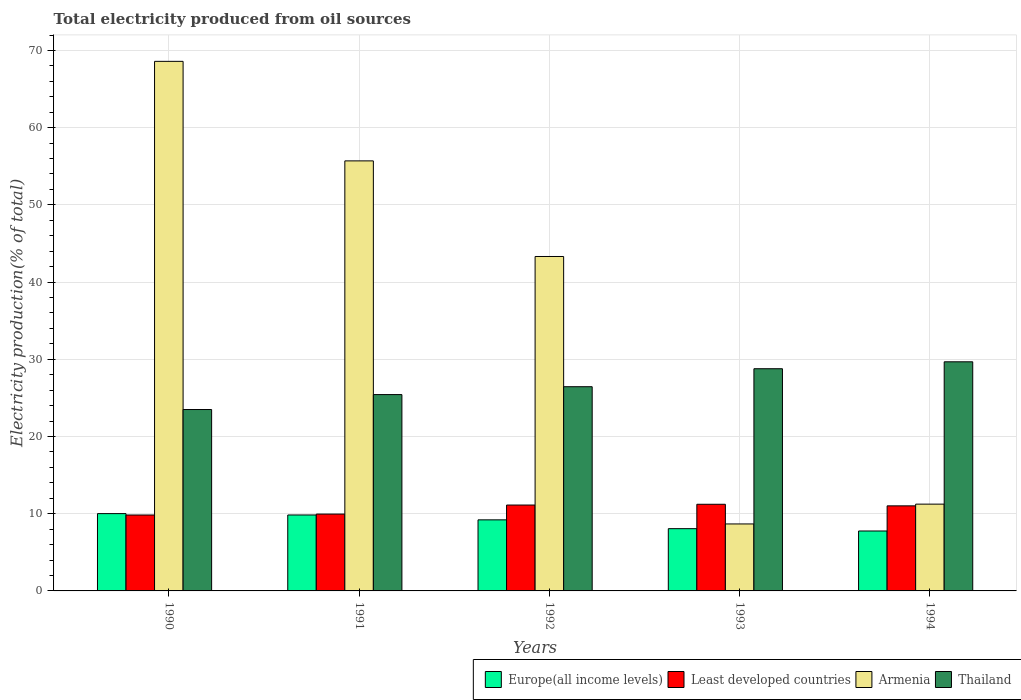How many bars are there on the 2nd tick from the right?
Keep it short and to the point. 4. What is the label of the 3rd group of bars from the left?
Provide a succinct answer. 1992. In how many cases, is the number of bars for a given year not equal to the number of legend labels?
Make the answer very short. 0. What is the total electricity produced in Least developed countries in 1991?
Your answer should be compact. 9.95. Across all years, what is the maximum total electricity produced in Thailand?
Offer a very short reply. 29.67. Across all years, what is the minimum total electricity produced in Armenia?
Make the answer very short. 8.67. What is the total total electricity produced in Europe(all income levels) in the graph?
Offer a terse response. 44.88. What is the difference between the total electricity produced in Armenia in 1993 and that in 1994?
Give a very brief answer. -2.57. What is the difference between the total electricity produced in Europe(all income levels) in 1994 and the total electricity produced in Thailand in 1990?
Give a very brief answer. -15.73. What is the average total electricity produced in Thailand per year?
Ensure brevity in your answer.  26.76. In the year 1993, what is the difference between the total electricity produced in Thailand and total electricity produced in Armenia?
Offer a terse response. 20.1. In how many years, is the total electricity produced in Least developed countries greater than 34 %?
Provide a short and direct response. 0. What is the ratio of the total electricity produced in Europe(all income levels) in 1990 to that in 1994?
Offer a terse response. 1.29. Is the total electricity produced in Armenia in 1990 less than that in 1992?
Your answer should be compact. No. What is the difference between the highest and the second highest total electricity produced in Least developed countries?
Ensure brevity in your answer.  0.1. What is the difference between the highest and the lowest total electricity produced in Least developed countries?
Provide a short and direct response. 1.39. In how many years, is the total electricity produced in Thailand greater than the average total electricity produced in Thailand taken over all years?
Your response must be concise. 2. Is it the case that in every year, the sum of the total electricity produced in Thailand and total electricity produced in Least developed countries is greater than the sum of total electricity produced in Europe(all income levels) and total electricity produced in Armenia?
Ensure brevity in your answer.  Yes. What does the 1st bar from the left in 1994 represents?
Your answer should be compact. Europe(all income levels). What does the 4th bar from the right in 1990 represents?
Offer a very short reply. Europe(all income levels). How many years are there in the graph?
Your answer should be compact. 5. What is the difference between two consecutive major ticks on the Y-axis?
Offer a terse response. 10. Are the values on the major ticks of Y-axis written in scientific E-notation?
Provide a short and direct response. No. How are the legend labels stacked?
Your answer should be compact. Horizontal. What is the title of the graph?
Your answer should be compact. Total electricity produced from oil sources. Does "Isle of Man" appear as one of the legend labels in the graph?
Keep it short and to the point. No. What is the label or title of the X-axis?
Your answer should be very brief. Years. What is the Electricity production(% of total) of Europe(all income levels) in 1990?
Give a very brief answer. 10.01. What is the Electricity production(% of total) in Least developed countries in 1990?
Provide a short and direct response. 9.83. What is the Electricity production(% of total) in Armenia in 1990?
Ensure brevity in your answer.  68.59. What is the Electricity production(% of total) of Thailand in 1990?
Make the answer very short. 23.49. What is the Electricity production(% of total) in Europe(all income levels) in 1991?
Give a very brief answer. 9.84. What is the Electricity production(% of total) of Least developed countries in 1991?
Give a very brief answer. 9.95. What is the Electricity production(% of total) in Armenia in 1991?
Give a very brief answer. 55.7. What is the Electricity production(% of total) of Thailand in 1991?
Provide a succinct answer. 25.43. What is the Electricity production(% of total) of Europe(all income levels) in 1992?
Provide a succinct answer. 9.2. What is the Electricity production(% of total) in Least developed countries in 1992?
Make the answer very short. 11.12. What is the Electricity production(% of total) in Armenia in 1992?
Ensure brevity in your answer.  43.31. What is the Electricity production(% of total) in Thailand in 1992?
Offer a very short reply. 26.45. What is the Electricity production(% of total) of Europe(all income levels) in 1993?
Give a very brief answer. 8.06. What is the Electricity production(% of total) of Least developed countries in 1993?
Make the answer very short. 11.22. What is the Electricity production(% of total) in Armenia in 1993?
Provide a succinct answer. 8.67. What is the Electricity production(% of total) of Thailand in 1993?
Give a very brief answer. 28.78. What is the Electricity production(% of total) of Europe(all income levels) in 1994?
Your answer should be very brief. 7.76. What is the Electricity production(% of total) of Least developed countries in 1994?
Make the answer very short. 11.02. What is the Electricity production(% of total) of Armenia in 1994?
Keep it short and to the point. 11.24. What is the Electricity production(% of total) in Thailand in 1994?
Provide a short and direct response. 29.67. Across all years, what is the maximum Electricity production(% of total) of Europe(all income levels)?
Give a very brief answer. 10.01. Across all years, what is the maximum Electricity production(% of total) of Least developed countries?
Provide a succinct answer. 11.22. Across all years, what is the maximum Electricity production(% of total) in Armenia?
Ensure brevity in your answer.  68.59. Across all years, what is the maximum Electricity production(% of total) of Thailand?
Your answer should be compact. 29.67. Across all years, what is the minimum Electricity production(% of total) in Europe(all income levels)?
Your answer should be very brief. 7.76. Across all years, what is the minimum Electricity production(% of total) of Least developed countries?
Your response must be concise. 9.83. Across all years, what is the minimum Electricity production(% of total) in Armenia?
Keep it short and to the point. 8.67. Across all years, what is the minimum Electricity production(% of total) in Thailand?
Provide a short and direct response. 23.49. What is the total Electricity production(% of total) of Europe(all income levels) in the graph?
Provide a short and direct response. 44.88. What is the total Electricity production(% of total) in Least developed countries in the graph?
Give a very brief answer. 53.15. What is the total Electricity production(% of total) in Armenia in the graph?
Ensure brevity in your answer.  187.51. What is the total Electricity production(% of total) in Thailand in the graph?
Offer a very short reply. 133.82. What is the difference between the Electricity production(% of total) in Europe(all income levels) in 1990 and that in 1991?
Your response must be concise. 0.18. What is the difference between the Electricity production(% of total) in Least developed countries in 1990 and that in 1991?
Make the answer very short. -0.12. What is the difference between the Electricity production(% of total) of Armenia in 1990 and that in 1991?
Your response must be concise. 12.89. What is the difference between the Electricity production(% of total) of Thailand in 1990 and that in 1991?
Offer a very short reply. -1.93. What is the difference between the Electricity production(% of total) in Europe(all income levels) in 1990 and that in 1992?
Give a very brief answer. 0.81. What is the difference between the Electricity production(% of total) of Least developed countries in 1990 and that in 1992?
Ensure brevity in your answer.  -1.29. What is the difference between the Electricity production(% of total) in Armenia in 1990 and that in 1992?
Keep it short and to the point. 25.27. What is the difference between the Electricity production(% of total) in Thailand in 1990 and that in 1992?
Offer a very short reply. -2.95. What is the difference between the Electricity production(% of total) of Europe(all income levels) in 1990 and that in 1993?
Give a very brief answer. 1.95. What is the difference between the Electricity production(% of total) in Least developed countries in 1990 and that in 1993?
Keep it short and to the point. -1.39. What is the difference between the Electricity production(% of total) of Armenia in 1990 and that in 1993?
Provide a short and direct response. 59.91. What is the difference between the Electricity production(% of total) in Thailand in 1990 and that in 1993?
Make the answer very short. -5.28. What is the difference between the Electricity production(% of total) in Europe(all income levels) in 1990 and that in 1994?
Ensure brevity in your answer.  2.25. What is the difference between the Electricity production(% of total) in Least developed countries in 1990 and that in 1994?
Keep it short and to the point. -1.19. What is the difference between the Electricity production(% of total) in Armenia in 1990 and that in 1994?
Ensure brevity in your answer.  57.35. What is the difference between the Electricity production(% of total) of Thailand in 1990 and that in 1994?
Your response must be concise. -6.18. What is the difference between the Electricity production(% of total) of Europe(all income levels) in 1991 and that in 1992?
Provide a succinct answer. 0.63. What is the difference between the Electricity production(% of total) in Least developed countries in 1991 and that in 1992?
Offer a very short reply. -1.17. What is the difference between the Electricity production(% of total) of Armenia in 1991 and that in 1992?
Keep it short and to the point. 12.38. What is the difference between the Electricity production(% of total) in Thailand in 1991 and that in 1992?
Offer a very short reply. -1.02. What is the difference between the Electricity production(% of total) of Europe(all income levels) in 1991 and that in 1993?
Give a very brief answer. 1.77. What is the difference between the Electricity production(% of total) of Least developed countries in 1991 and that in 1993?
Provide a short and direct response. -1.27. What is the difference between the Electricity production(% of total) of Armenia in 1991 and that in 1993?
Offer a very short reply. 47.02. What is the difference between the Electricity production(% of total) of Thailand in 1991 and that in 1993?
Your answer should be very brief. -3.35. What is the difference between the Electricity production(% of total) of Europe(all income levels) in 1991 and that in 1994?
Provide a succinct answer. 2.08. What is the difference between the Electricity production(% of total) of Least developed countries in 1991 and that in 1994?
Ensure brevity in your answer.  -1.06. What is the difference between the Electricity production(% of total) of Armenia in 1991 and that in 1994?
Make the answer very short. 44.45. What is the difference between the Electricity production(% of total) of Thailand in 1991 and that in 1994?
Offer a terse response. -4.25. What is the difference between the Electricity production(% of total) of Europe(all income levels) in 1992 and that in 1993?
Your answer should be very brief. 1.14. What is the difference between the Electricity production(% of total) in Least developed countries in 1992 and that in 1993?
Give a very brief answer. -0.1. What is the difference between the Electricity production(% of total) of Armenia in 1992 and that in 1993?
Make the answer very short. 34.64. What is the difference between the Electricity production(% of total) in Thailand in 1992 and that in 1993?
Your answer should be compact. -2.33. What is the difference between the Electricity production(% of total) of Europe(all income levels) in 1992 and that in 1994?
Provide a succinct answer. 1.44. What is the difference between the Electricity production(% of total) in Least developed countries in 1992 and that in 1994?
Make the answer very short. 0.11. What is the difference between the Electricity production(% of total) in Armenia in 1992 and that in 1994?
Provide a succinct answer. 32.07. What is the difference between the Electricity production(% of total) in Thailand in 1992 and that in 1994?
Offer a terse response. -3.23. What is the difference between the Electricity production(% of total) of Europe(all income levels) in 1993 and that in 1994?
Provide a succinct answer. 0.3. What is the difference between the Electricity production(% of total) of Least developed countries in 1993 and that in 1994?
Your response must be concise. 0.21. What is the difference between the Electricity production(% of total) in Armenia in 1993 and that in 1994?
Keep it short and to the point. -2.57. What is the difference between the Electricity production(% of total) in Thailand in 1993 and that in 1994?
Keep it short and to the point. -0.9. What is the difference between the Electricity production(% of total) of Europe(all income levels) in 1990 and the Electricity production(% of total) of Least developed countries in 1991?
Your answer should be very brief. 0.06. What is the difference between the Electricity production(% of total) in Europe(all income levels) in 1990 and the Electricity production(% of total) in Armenia in 1991?
Make the answer very short. -45.68. What is the difference between the Electricity production(% of total) in Europe(all income levels) in 1990 and the Electricity production(% of total) in Thailand in 1991?
Keep it short and to the point. -15.42. What is the difference between the Electricity production(% of total) of Least developed countries in 1990 and the Electricity production(% of total) of Armenia in 1991?
Ensure brevity in your answer.  -45.86. What is the difference between the Electricity production(% of total) in Least developed countries in 1990 and the Electricity production(% of total) in Thailand in 1991?
Your answer should be very brief. -15.6. What is the difference between the Electricity production(% of total) of Armenia in 1990 and the Electricity production(% of total) of Thailand in 1991?
Your answer should be compact. 43.16. What is the difference between the Electricity production(% of total) of Europe(all income levels) in 1990 and the Electricity production(% of total) of Least developed countries in 1992?
Make the answer very short. -1.11. What is the difference between the Electricity production(% of total) of Europe(all income levels) in 1990 and the Electricity production(% of total) of Armenia in 1992?
Your answer should be compact. -33.3. What is the difference between the Electricity production(% of total) of Europe(all income levels) in 1990 and the Electricity production(% of total) of Thailand in 1992?
Offer a terse response. -16.44. What is the difference between the Electricity production(% of total) of Least developed countries in 1990 and the Electricity production(% of total) of Armenia in 1992?
Provide a short and direct response. -33.48. What is the difference between the Electricity production(% of total) of Least developed countries in 1990 and the Electricity production(% of total) of Thailand in 1992?
Give a very brief answer. -16.62. What is the difference between the Electricity production(% of total) of Armenia in 1990 and the Electricity production(% of total) of Thailand in 1992?
Keep it short and to the point. 42.14. What is the difference between the Electricity production(% of total) in Europe(all income levels) in 1990 and the Electricity production(% of total) in Least developed countries in 1993?
Provide a short and direct response. -1.21. What is the difference between the Electricity production(% of total) in Europe(all income levels) in 1990 and the Electricity production(% of total) in Armenia in 1993?
Provide a short and direct response. 1.34. What is the difference between the Electricity production(% of total) of Europe(all income levels) in 1990 and the Electricity production(% of total) of Thailand in 1993?
Provide a succinct answer. -18.77. What is the difference between the Electricity production(% of total) of Least developed countries in 1990 and the Electricity production(% of total) of Armenia in 1993?
Keep it short and to the point. 1.16. What is the difference between the Electricity production(% of total) of Least developed countries in 1990 and the Electricity production(% of total) of Thailand in 1993?
Make the answer very short. -18.95. What is the difference between the Electricity production(% of total) in Armenia in 1990 and the Electricity production(% of total) in Thailand in 1993?
Make the answer very short. 39.81. What is the difference between the Electricity production(% of total) in Europe(all income levels) in 1990 and the Electricity production(% of total) in Least developed countries in 1994?
Make the answer very short. -1.01. What is the difference between the Electricity production(% of total) of Europe(all income levels) in 1990 and the Electricity production(% of total) of Armenia in 1994?
Keep it short and to the point. -1.23. What is the difference between the Electricity production(% of total) in Europe(all income levels) in 1990 and the Electricity production(% of total) in Thailand in 1994?
Give a very brief answer. -19.66. What is the difference between the Electricity production(% of total) in Least developed countries in 1990 and the Electricity production(% of total) in Armenia in 1994?
Provide a short and direct response. -1.41. What is the difference between the Electricity production(% of total) in Least developed countries in 1990 and the Electricity production(% of total) in Thailand in 1994?
Offer a terse response. -19.84. What is the difference between the Electricity production(% of total) in Armenia in 1990 and the Electricity production(% of total) in Thailand in 1994?
Your response must be concise. 38.91. What is the difference between the Electricity production(% of total) of Europe(all income levels) in 1991 and the Electricity production(% of total) of Least developed countries in 1992?
Provide a short and direct response. -1.29. What is the difference between the Electricity production(% of total) in Europe(all income levels) in 1991 and the Electricity production(% of total) in Armenia in 1992?
Your answer should be compact. -33.48. What is the difference between the Electricity production(% of total) of Europe(all income levels) in 1991 and the Electricity production(% of total) of Thailand in 1992?
Ensure brevity in your answer.  -16.61. What is the difference between the Electricity production(% of total) in Least developed countries in 1991 and the Electricity production(% of total) in Armenia in 1992?
Ensure brevity in your answer.  -33.36. What is the difference between the Electricity production(% of total) of Least developed countries in 1991 and the Electricity production(% of total) of Thailand in 1992?
Ensure brevity in your answer.  -16.49. What is the difference between the Electricity production(% of total) of Armenia in 1991 and the Electricity production(% of total) of Thailand in 1992?
Provide a succinct answer. 29.25. What is the difference between the Electricity production(% of total) in Europe(all income levels) in 1991 and the Electricity production(% of total) in Least developed countries in 1993?
Provide a succinct answer. -1.39. What is the difference between the Electricity production(% of total) of Europe(all income levels) in 1991 and the Electricity production(% of total) of Armenia in 1993?
Offer a very short reply. 1.16. What is the difference between the Electricity production(% of total) in Europe(all income levels) in 1991 and the Electricity production(% of total) in Thailand in 1993?
Give a very brief answer. -18.94. What is the difference between the Electricity production(% of total) of Least developed countries in 1991 and the Electricity production(% of total) of Armenia in 1993?
Your answer should be very brief. 1.28. What is the difference between the Electricity production(% of total) of Least developed countries in 1991 and the Electricity production(% of total) of Thailand in 1993?
Your response must be concise. -18.82. What is the difference between the Electricity production(% of total) of Armenia in 1991 and the Electricity production(% of total) of Thailand in 1993?
Make the answer very short. 26.92. What is the difference between the Electricity production(% of total) of Europe(all income levels) in 1991 and the Electricity production(% of total) of Least developed countries in 1994?
Ensure brevity in your answer.  -1.18. What is the difference between the Electricity production(% of total) in Europe(all income levels) in 1991 and the Electricity production(% of total) in Armenia in 1994?
Offer a terse response. -1.4. What is the difference between the Electricity production(% of total) in Europe(all income levels) in 1991 and the Electricity production(% of total) in Thailand in 1994?
Ensure brevity in your answer.  -19.84. What is the difference between the Electricity production(% of total) in Least developed countries in 1991 and the Electricity production(% of total) in Armenia in 1994?
Your answer should be very brief. -1.29. What is the difference between the Electricity production(% of total) of Least developed countries in 1991 and the Electricity production(% of total) of Thailand in 1994?
Your response must be concise. -19.72. What is the difference between the Electricity production(% of total) of Armenia in 1991 and the Electricity production(% of total) of Thailand in 1994?
Offer a very short reply. 26.02. What is the difference between the Electricity production(% of total) of Europe(all income levels) in 1992 and the Electricity production(% of total) of Least developed countries in 1993?
Offer a very short reply. -2.02. What is the difference between the Electricity production(% of total) in Europe(all income levels) in 1992 and the Electricity production(% of total) in Armenia in 1993?
Your answer should be very brief. 0.53. What is the difference between the Electricity production(% of total) of Europe(all income levels) in 1992 and the Electricity production(% of total) of Thailand in 1993?
Ensure brevity in your answer.  -19.57. What is the difference between the Electricity production(% of total) of Least developed countries in 1992 and the Electricity production(% of total) of Armenia in 1993?
Provide a short and direct response. 2.45. What is the difference between the Electricity production(% of total) in Least developed countries in 1992 and the Electricity production(% of total) in Thailand in 1993?
Provide a short and direct response. -17.66. What is the difference between the Electricity production(% of total) in Armenia in 1992 and the Electricity production(% of total) in Thailand in 1993?
Give a very brief answer. 14.54. What is the difference between the Electricity production(% of total) of Europe(all income levels) in 1992 and the Electricity production(% of total) of Least developed countries in 1994?
Make the answer very short. -1.81. What is the difference between the Electricity production(% of total) of Europe(all income levels) in 1992 and the Electricity production(% of total) of Armenia in 1994?
Offer a very short reply. -2.04. What is the difference between the Electricity production(% of total) of Europe(all income levels) in 1992 and the Electricity production(% of total) of Thailand in 1994?
Your answer should be very brief. -20.47. What is the difference between the Electricity production(% of total) of Least developed countries in 1992 and the Electricity production(% of total) of Armenia in 1994?
Your response must be concise. -0.12. What is the difference between the Electricity production(% of total) in Least developed countries in 1992 and the Electricity production(% of total) in Thailand in 1994?
Provide a succinct answer. -18.55. What is the difference between the Electricity production(% of total) of Armenia in 1992 and the Electricity production(% of total) of Thailand in 1994?
Offer a terse response. 13.64. What is the difference between the Electricity production(% of total) of Europe(all income levels) in 1993 and the Electricity production(% of total) of Least developed countries in 1994?
Give a very brief answer. -2.95. What is the difference between the Electricity production(% of total) in Europe(all income levels) in 1993 and the Electricity production(% of total) in Armenia in 1994?
Provide a succinct answer. -3.18. What is the difference between the Electricity production(% of total) of Europe(all income levels) in 1993 and the Electricity production(% of total) of Thailand in 1994?
Your response must be concise. -21.61. What is the difference between the Electricity production(% of total) in Least developed countries in 1993 and the Electricity production(% of total) in Armenia in 1994?
Your answer should be very brief. -0.02. What is the difference between the Electricity production(% of total) of Least developed countries in 1993 and the Electricity production(% of total) of Thailand in 1994?
Provide a succinct answer. -18.45. What is the difference between the Electricity production(% of total) in Armenia in 1993 and the Electricity production(% of total) in Thailand in 1994?
Give a very brief answer. -21. What is the average Electricity production(% of total) in Europe(all income levels) per year?
Offer a very short reply. 8.98. What is the average Electricity production(% of total) in Least developed countries per year?
Ensure brevity in your answer.  10.63. What is the average Electricity production(% of total) of Armenia per year?
Ensure brevity in your answer.  37.5. What is the average Electricity production(% of total) in Thailand per year?
Your answer should be very brief. 26.76. In the year 1990, what is the difference between the Electricity production(% of total) in Europe(all income levels) and Electricity production(% of total) in Least developed countries?
Your answer should be compact. 0.18. In the year 1990, what is the difference between the Electricity production(% of total) in Europe(all income levels) and Electricity production(% of total) in Armenia?
Provide a succinct answer. -58.58. In the year 1990, what is the difference between the Electricity production(% of total) of Europe(all income levels) and Electricity production(% of total) of Thailand?
Offer a terse response. -13.48. In the year 1990, what is the difference between the Electricity production(% of total) of Least developed countries and Electricity production(% of total) of Armenia?
Offer a terse response. -58.76. In the year 1990, what is the difference between the Electricity production(% of total) in Least developed countries and Electricity production(% of total) in Thailand?
Your response must be concise. -13.66. In the year 1990, what is the difference between the Electricity production(% of total) of Armenia and Electricity production(% of total) of Thailand?
Offer a terse response. 45.09. In the year 1991, what is the difference between the Electricity production(% of total) of Europe(all income levels) and Electricity production(% of total) of Least developed countries?
Your response must be concise. -0.12. In the year 1991, what is the difference between the Electricity production(% of total) in Europe(all income levels) and Electricity production(% of total) in Armenia?
Your answer should be compact. -45.86. In the year 1991, what is the difference between the Electricity production(% of total) in Europe(all income levels) and Electricity production(% of total) in Thailand?
Provide a short and direct response. -15.59. In the year 1991, what is the difference between the Electricity production(% of total) in Least developed countries and Electricity production(% of total) in Armenia?
Your answer should be very brief. -45.74. In the year 1991, what is the difference between the Electricity production(% of total) in Least developed countries and Electricity production(% of total) in Thailand?
Make the answer very short. -15.47. In the year 1991, what is the difference between the Electricity production(% of total) of Armenia and Electricity production(% of total) of Thailand?
Provide a succinct answer. 30.27. In the year 1992, what is the difference between the Electricity production(% of total) in Europe(all income levels) and Electricity production(% of total) in Least developed countries?
Provide a short and direct response. -1.92. In the year 1992, what is the difference between the Electricity production(% of total) in Europe(all income levels) and Electricity production(% of total) in Armenia?
Your response must be concise. -34.11. In the year 1992, what is the difference between the Electricity production(% of total) of Europe(all income levels) and Electricity production(% of total) of Thailand?
Your answer should be compact. -17.24. In the year 1992, what is the difference between the Electricity production(% of total) in Least developed countries and Electricity production(% of total) in Armenia?
Your answer should be very brief. -32.19. In the year 1992, what is the difference between the Electricity production(% of total) of Least developed countries and Electricity production(% of total) of Thailand?
Provide a succinct answer. -15.33. In the year 1992, what is the difference between the Electricity production(% of total) in Armenia and Electricity production(% of total) in Thailand?
Keep it short and to the point. 16.87. In the year 1993, what is the difference between the Electricity production(% of total) of Europe(all income levels) and Electricity production(% of total) of Least developed countries?
Ensure brevity in your answer.  -3.16. In the year 1993, what is the difference between the Electricity production(% of total) of Europe(all income levels) and Electricity production(% of total) of Armenia?
Ensure brevity in your answer.  -0.61. In the year 1993, what is the difference between the Electricity production(% of total) in Europe(all income levels) and Electricity production(% of total) in Thailand?
Your answer should be compact. -20.71. In the year 1993, what is the difference between the Electricity production(% of total) in Least developed countries and Electricity production(% of total) in Armenia?
Give a very brief answer. 2.55. In the year 1993, what is the difference between the Electricity production(% of total) of Least developed countries and Electricity production(% of total) of Thailand?
Give a very brief answer. -17.55. In the year 1993, what is the difference between the Electricity production(% of total) in Armenia and Electricity production(% of total) in Thailand?
Provide a succinct answer. -20.1. In the year 1994, what is the difference between the Electricity production(% of total) of Europe(all income levels) and Electricity production(% of total) of Least developed countries?
Your answer should be very brief. -3.26. In the year 1994, what is the difference between the Electricity production(% of total) in Europe(all income levels) and Electricity production(% of total) in Armenia?
Make the answer very short. -3.48. In the year 1994, what is the difference between the Electricity production(% of total) of Europe(all income levels) and Electricity production(% of total) of Thailand?
Provide a succinct answer. -21.91. In the year 1994, what is the difference between the Electricity production(% of total) in Least developed countries and Electricity production(% of total) in Armenia?
Ensure brevity in your answer.  -0.22. In the year 1994, what is the difference between the Electricity production(% of total) in Least developed countries and Electricity production(% of total) in Thailand?
Offer a terse response. -18.66. In the year 1994, what is the difference between the Electricity production(% of total) in Armenia and Electricity production(% of total) in Thailand?
Ensure brevity in your answer.  -18.43. What is the ratio of the Electricity production(% of total) of Europe(all income levels) in 1990 to that in 1991?
Your answer should be compact. 1.02. What is the ratio of the Electricity production(% of total) in Least developed countries in 1990 to that in 1991?
Offer a very short reply. 0.99. What is the ratio of the Electricity production(% of total) in Armenia in 1990 to that in 1991?
Offer a very short reply. 1.23. What is the ratio of the Electricity production(% of total) in Thailand in 1990 to that in 1991?
Offer a very short reply. 0.92. What is the ratio of the Electricity production(% of total) in Europe(all income levels) in 1990 to that in 1992?
Offer a terse response. 1.09. What is the ratio of the Electricity production(% of total) of Least developed countries in 1990 to that in 1992?
Ensure brevity in your answer.  0.88. What is the ratio of the Electricity production(% of total) in Armenia in 1990 to that in 1992?
Give a very brief answer. 1.58. What is the ratio of the Electricity production(% of total) of Thailand in 1990 to that in 1992?
Your answer should be compact. 0.89. What is the ratio of the Electricity production(% of total) in Europe(all income levels) in 1990 to that in 1993?
Your answer should be very brief. 1.24. What is the ratio of the Electricity production(% of total) of Least developed countries in 1990 to that in 1993?
Keep it short and to the point. 0.88. What is the ratio of the Electricity production(% of total) in Armenia in 1990 to that in 1993?
Ensure brevity in your answer.  7.91. What is the ratio of the Electricity production(% of total) of Thailand in 1990 to that in 1993?
Your answer should be very brief. 0.82. What is the ratio of the Electricity production(% of total) of Europe(all income levels) in 1990 to that in 1994?
Make the answer very short. 1.29. What is the ratio of the Electricity production(% of total) of Least developed countries in 1990 to that in 1994?
Provide a succinct answer. 0.89. What is the ratio of the Electricity production(% of total) of Armenia in 1990 to that in 1994?
Keep it short and to the point. 6.1. What is the ratio of the Electricity production(% of total) in Thailand in 1990 to that in 1994?
Ensure brevity in your answer.  0.79. What is the ratio of the Electricity production(% of total) of Europe(all income levels) in 1991 to that in 1992?
Your response must be concise. 1.07. What is the ratio of the Electricity production(% of total) of Least developed countries in 1991 to that in 1992?
Provide a succinct answer. 0.89. What is the ratio of the Electricity production(% of total) in Armenia in 1991 to that in 1992?
Keep it short and to the point. 1.29. What is the ratio of the Electricity production(% of total) of Thailand in 1991 to that in 1992?
Make the answer very short. 0.96. What is the ratio of the Electricity production(% of total) of Europe(all income levels) in 1991 to that in 1993?
Make the answer very short. 1.22. What is the ratio of the Electricity production(% of total) in Least developed countries in 1991 to that in 1993?
Ensure brevity in your answer.  0.89. What is the ratio of the Electricity production(% of total) of Armenia in 1991 to that in 1993?
Give a very brief answer. 6.42. What is the ratio of the Electricity production(% of total) in Thailand in 1991 to that in 1993?
Keep it short and to the point. 0.88. What is the ratio of the Electricity production(% of total) in Europe(all income levels) in 1991 to that in 1994?
Your answer should be compact. 1.27. What is the ratio of the Electricity production(% of total) of Least developed countries in 1991 to that in 1994?
Keep it short and to the point. 0.9. What is the ratio of the Electricity production(% of total) in Armenia in 1991 to that in 1994?
Your answer should be very brief. 4.95. What is the ratio of the Electricity production(% of total) in Thailand in 1991 to that in 1994?
Your response must be concise. 0.86. What is the ratio of the Electricity production(% of total) of Europe(all income levels) in 1992 to that in 1993?
Give a very brief answer. 1.14. What is the ratio of the Electricity production(% of total) in Armenia in 1992 to that in 1993?
Ensure brevity in your answer.  4.99. What is the ratio of the Electricity production(% of total) in Thailand in 1992 to that in 1993?
Ensure brevity in your answer.  0.92. What is the ratio of the Electricity production(% of total) in Europe(all income levels) in 1992 to that in 1994?
Keep it short and to the point. 1.19. What is the ratio of the Electricity production(% of total) of Least developed countries in 1992 to that in 1994?
Provide a succinct answer. 1.01. What is the ratio of the Electricity production(% of total) in Armenia in 1992 to that in 1994?
Provide a short and direct response. 3.85. What is the ratio of the Electricity production(% of total) in Thailand in 1992 to that in 1994?
Offer a very short reply. 0.89. What is the ratio of the Electricity production(% of total) in Europe(all income levels) in 1993 to that in 1994?
Make the answer very short. 1.04. What is the ratio of the Electricity production(% of total) of Least developed countries in 1993 to that in 1994?
Your response must be concise. 1.02. What is the ratio of the Electricity production(% of total) in Armenia in 1993 to that in 1994?
Make the answer very short. 0.77. What is the ratio of the Electricity production(% of total) in Thailand in 1993 to that in 1994?
Offer a very short reply. 0.97. What is the difference between the highest and the second highest Electricity production(% of total) of Europe(all income levels)?
Your answer should be compact. 0.18. What is the difference between the highest and the second highest Electricity production(% of total) of Least developed countries?
Ensure brevity in your answer.  0.1. What is the difference between the highest and the second highest Electricity production(% of total) in Armenia?
Offer a terse response. 12.89. What is the difference between the highest and the second highest Electricity production(% of total) of Thailand?
Offer a terse response. 0.9. What is the difference between the highest and the lowest Electricity production(% of total) in Europe(all income levels)?
Offer a terse response. 2.25. What is the difference between the highest and the lowest Electricity production(% of total) in Least developed countries?
Provide a short and direct response. 1.39. What is the difference between the highest and the lowest Electricity production(% of total) in Armenia?
Offer a terse response. 59.91. What is the difference between the highest and the lowest Electricity production(% of total) in Thailand?
Give a very brief answer. 6.18. 